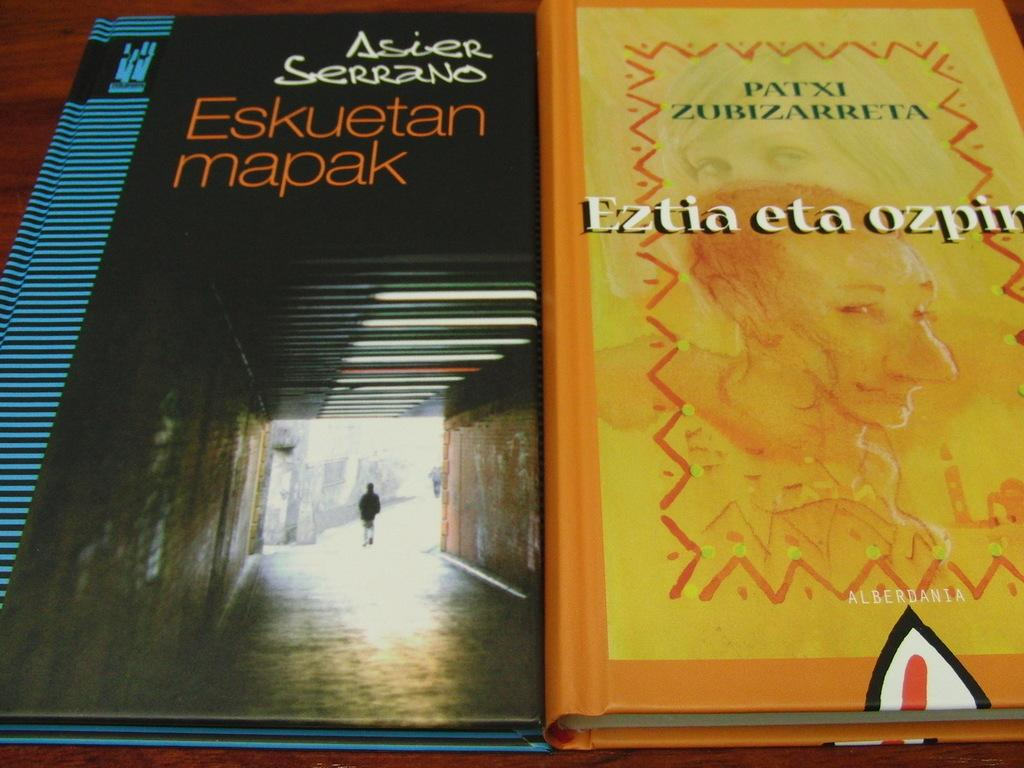<image>
Write a terse but informative summary of the picture. A book titled "Eskuetan Mapak" by Asier Serrano and "Eztia eta ozpin" by Patxi Bizarret. 